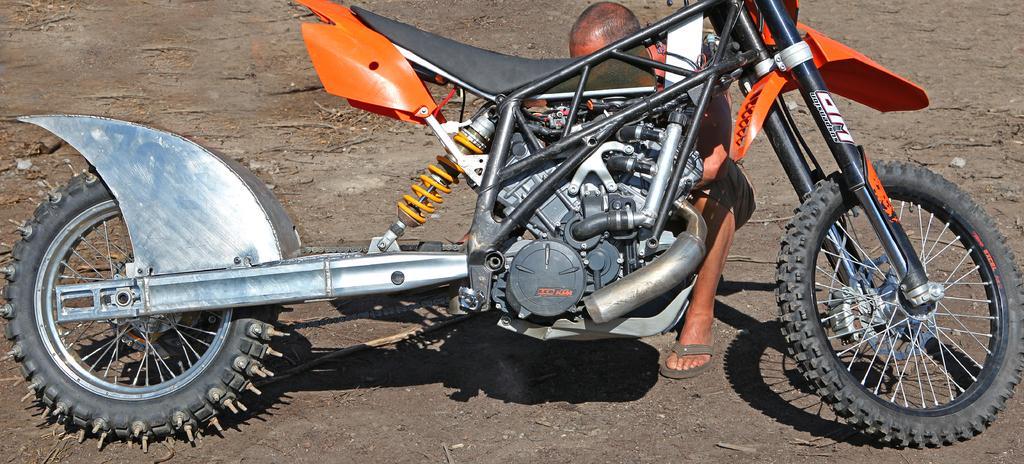Could you give a brief overview of what you see in this image? In this image I can see a motorcycle on the ground. Behind this motorcycle there is a person sitting. 